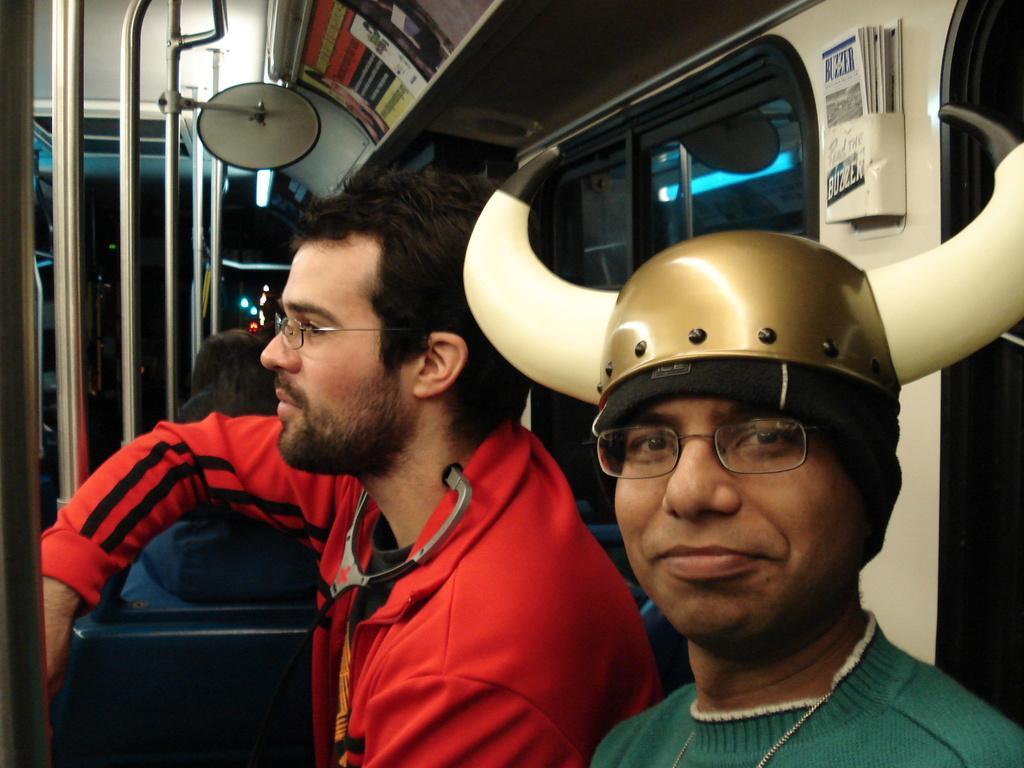In one or two sentences, can you explain what this image depicts? In front of the image there is a person wearing a helmet, beside him there is another person and there are some other people in the seats, in front of them there are metal rods, at the top there are some posters, behind them there are glass windows. 